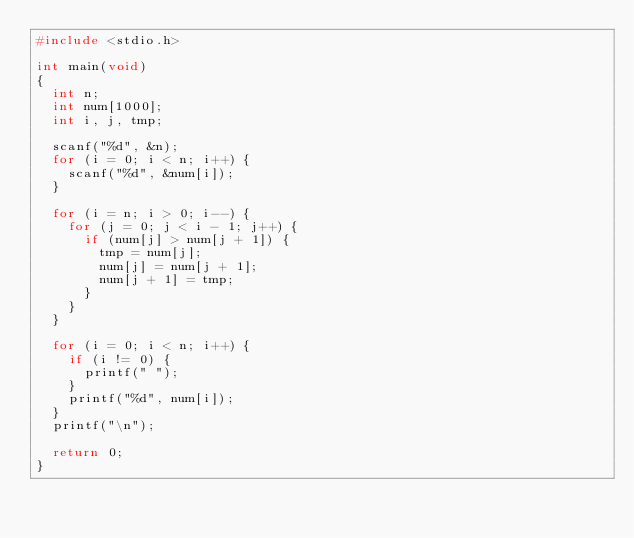<code> <loc_0><loc_0><loc_500><loc_500><_C_>#include <stdio.h>

int main(void)
{
  int n;
  int num[1000];
  int i, j, tmp;

  scanf("%d", &n);
  for (i = 0; i < n; i++) {
    scanf("%d", &num[i]);
  }

  for (i = n; i > 0; i--) {
    for (j = 0; j < i - 1; j++) {
      if (num[j] > num[j + 1]) {
        tmp = num[j];
        num[j] = num[j + 1];
        num[j + 1] = tmp;
      }
    }
  }

  for (i = 0; i < n; i++) {
    if (i != 0) {
      printf(" ");
    }
    printf("%d", num[i]);
  }
  printf("\n");

  return 0;
}</code> 